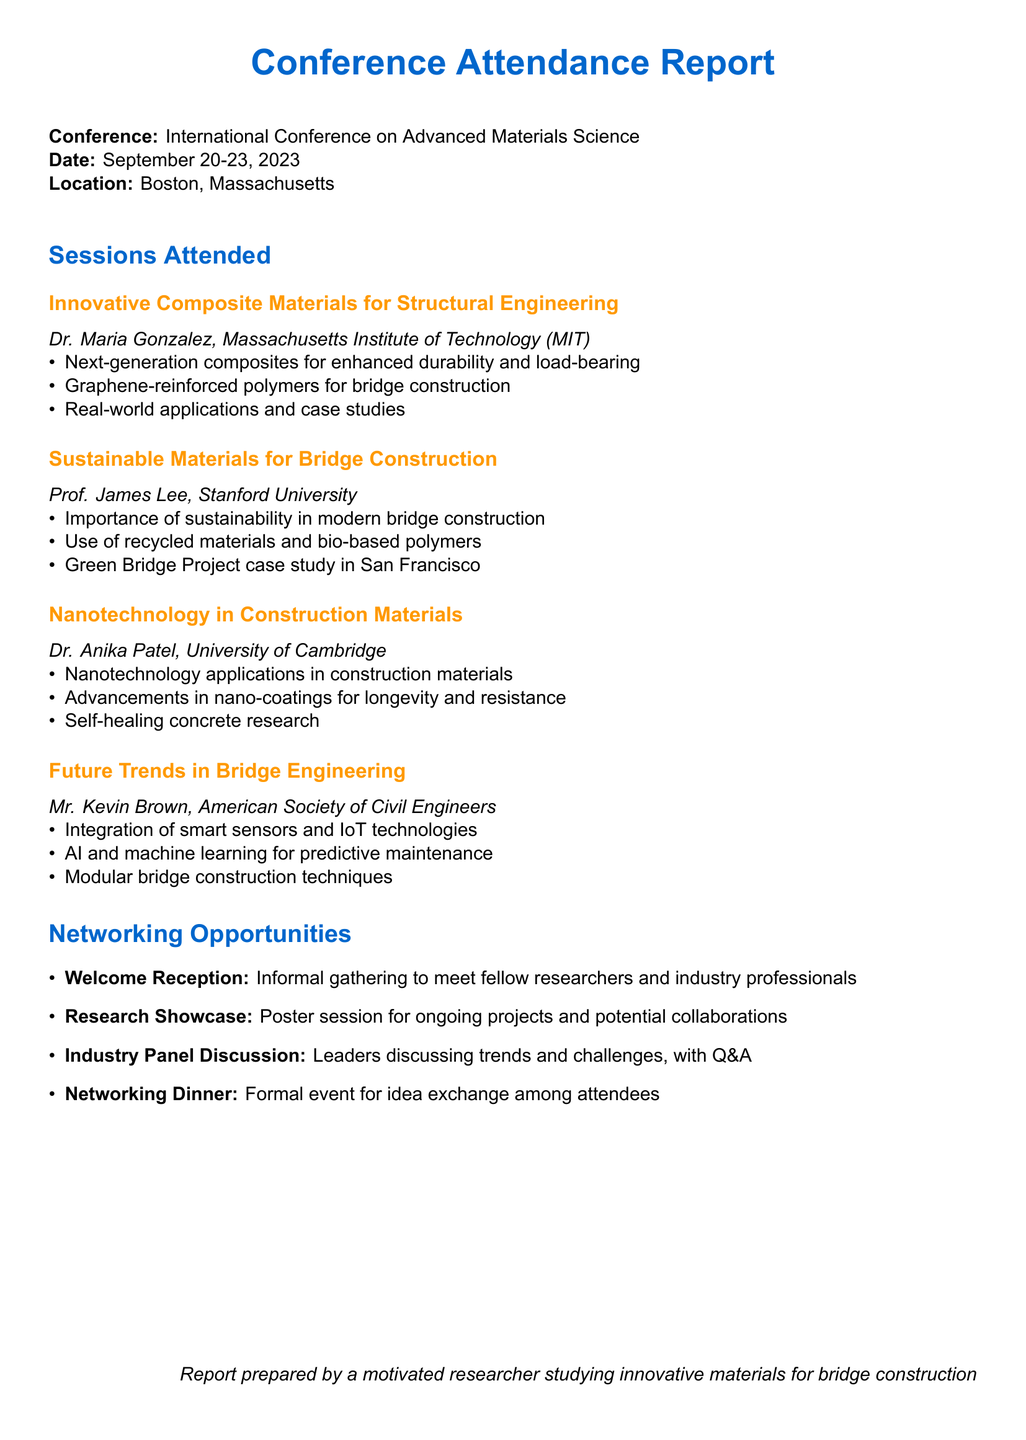What is the name of the conference? The conference is titled "International Conference on Advanced Materials Science."
Answer: International Conference on Advanced Materials Science When did the conference take place? The conference occurred from September 20 to September 23, 2023.
Answer: September 20-23, 2023 Who presented on sustainable materials for bridge construction? The session on sustainable materials was presented by Prof. James Lee.
Answer: Prof. James Lee What innovative technology was discussed by Dr. Anika Patel? Dr. Anika Patel discussed advancements in nano-coatings.
Answer: Advancements in nano-coatings Which university did Dr. Maria Gonzalez represent? Dr. Maria Gonzalez is from the Massachusetts Institute of Technology (MIT).
Answer: Massachusetts Institute of Technology (MIT) What was a key takeaway from the "Future Trends in Bridge Engineering" session? A key takeaway from this session was the integration of smart sensors and IoT technologies.
Answer: Integration of smart sensors and IoT technologies What networking opportunity involved a formal event? The formal networking opportunity was the Networking Dinner.
Answer: Networking Dinner Which case study was highlighted in the "Sustainable Materials for Bridge Construction" session? The Green Bridge Project was highlighted as a case study.
Answer: Green Bridge Project What type of reception was held at the conference? A Welcome Reception was held to meet fellow researchers and industry professionals.
Answer: Welcome Reception 